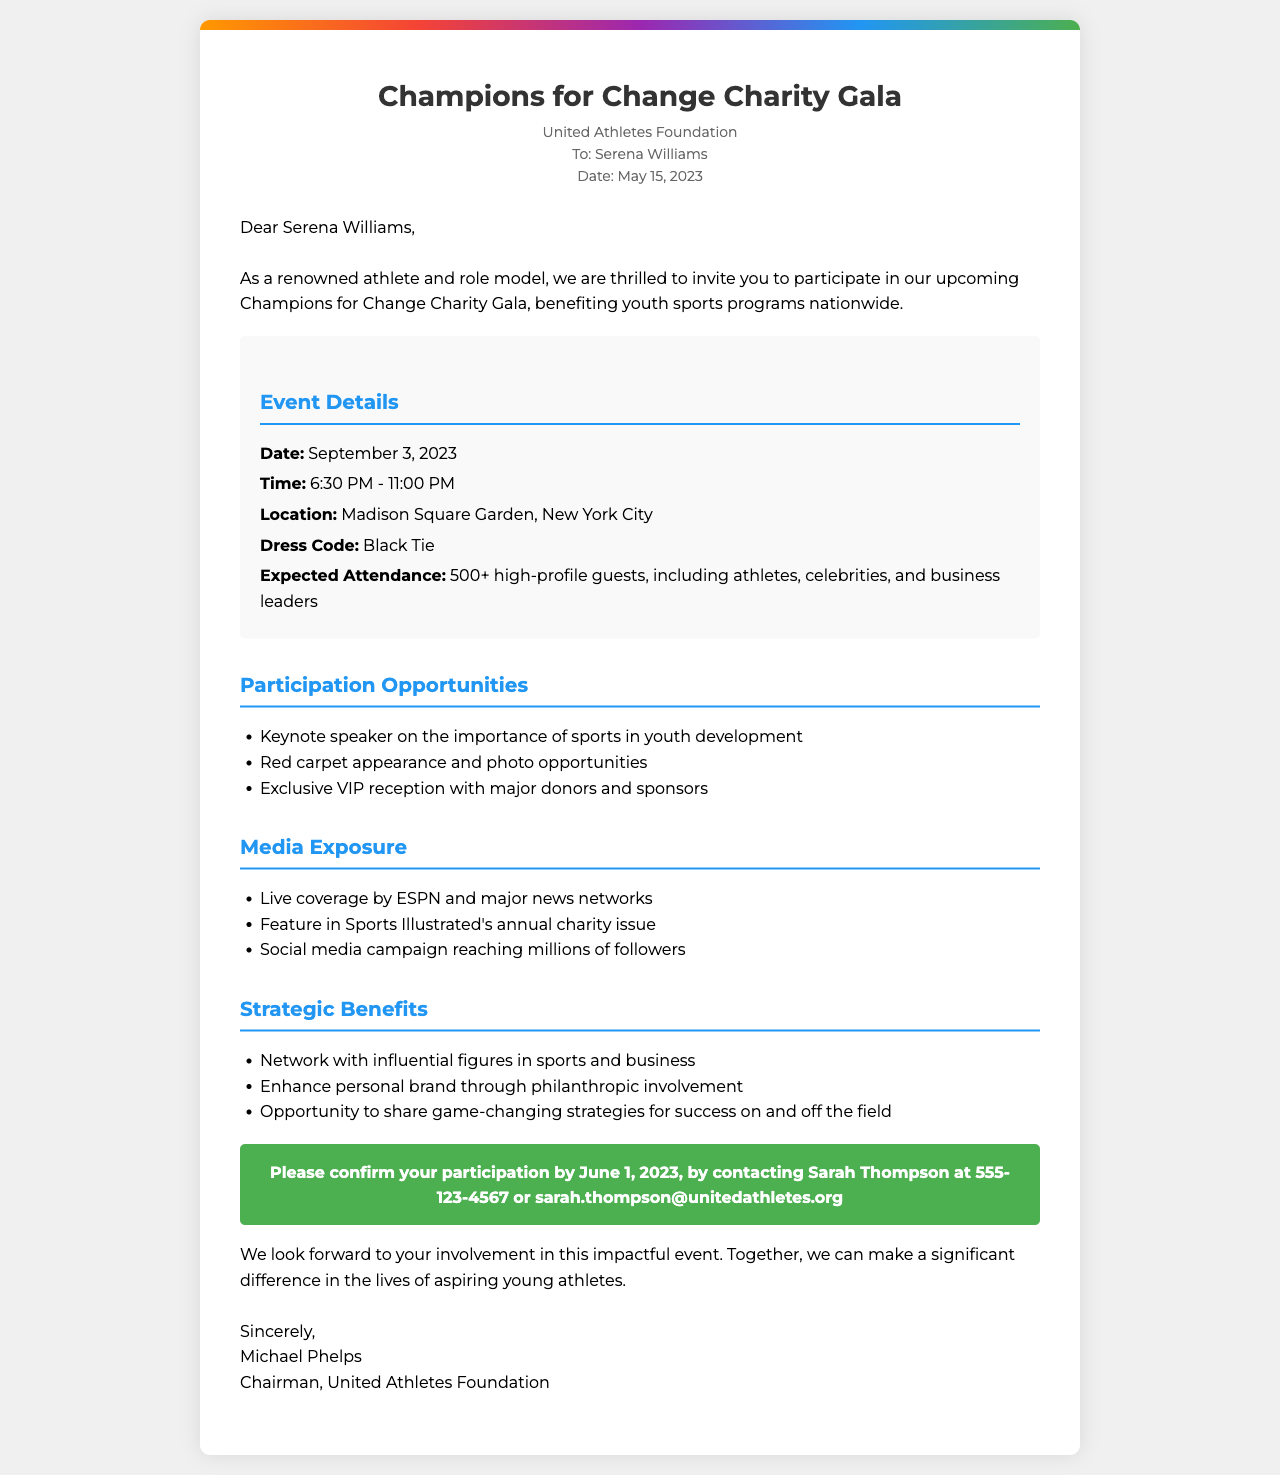What is the name of the charity gala? The document indicates that the charity gala is named "Champions for Change Charity Gala."
Answer: Champions for Change Charity Gala Who is the sender of the invitation? The sender is identified as the "United Athletes Foundation."
Answer: United Athletes Foundation What is the date of the event? The document specifies that the event is on "September 3, 2023."
Answer: September 3, 2023 What is the expected attendance for the event? The expected attendance is stated as "500+ high-profile guests."
Answer: 500+ high-profile guests What dress code is required for the gala? The invitation specifies a "Black Tie" dress code.
Answer: Black Tie What is one of the participation opportunities mentioned? One participation opportunity listed is being a "Keynote speaker on the importance of sports in youth development."
Answer: Keynote speaker on the importance of sports in youth development What type of media exposure will the event receive? The document states there will be "Live coverage by ESPN and major news networks."
Answer: Live coverage by ESPN and major news networks What should be the response date for confirmation? The document indicates the participation should be confirmed by "June 1, 2023."
Answer: June 1, 2023 Who is the closing signature of the letter? The closing signature of the letter is from "Michael Phelps."
Answer: Michael Phelps 